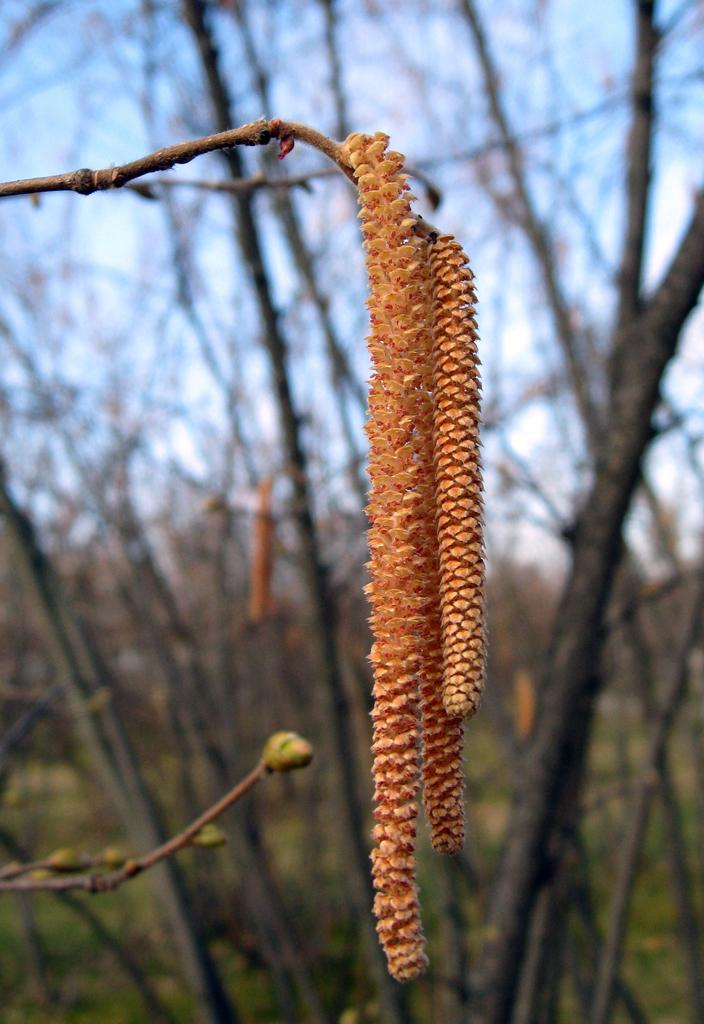What is the main subject of the image? There is a flower-like object in the image. What can be seen in the background of the image? There are trees and the sky visible in the background of the image. What type of blood can be seen dripping from the flower-like object in the image? There is no blood present in the image, and the flower-like object does not appear to be damaged or bleeding. 